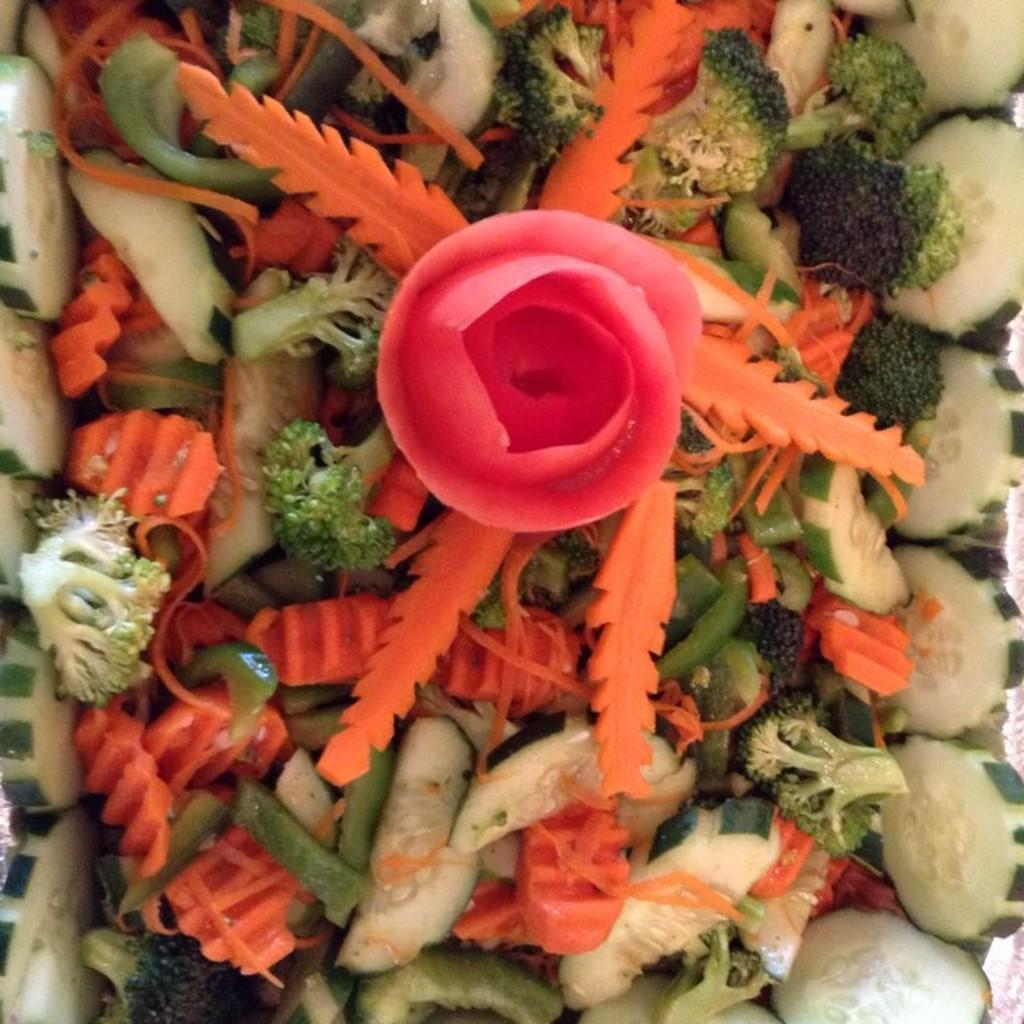Can you describe this image briefly? In this image I can see colourful chopped vegetables and I can also see a pink colour thing on the top of it. 